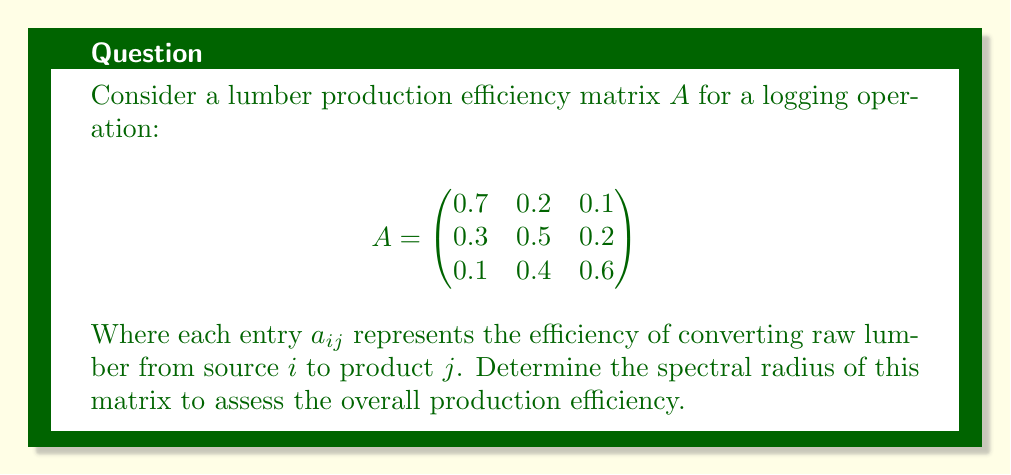Can you answer this question? To find the spectral radius of matrix $A$, we need to:

1) Find the characteristic polynomial:
   $det(A - \lambda I) = 0$
   
   $$\begin{vmatrix}
   0.7-\lambda & 0.2 & 0.1 \\
   0.3 & 0.5-\lambda & 0.2 \\
   0.1 & 0.4 & 0.6-\lambda
   \end{vmatrix} = 0$$

2) Expand the determinant:
   $(0.7-\lambda)[(0.5-\lambda)(0.6-\lambda)-0.08] - 0.2[0.3(0.6-\lambda)-0.02] + 0.1[0.12-0.3(0.5-\lambda)] = 0$

3) Simplify:
   $-\lambda^3 + 1.8\lambda^2 - 0.83\lambda + 0.116 = 0$

4) Find the roots of this polynomial. The largest absolute value of these roots is the spectral radius.

5) Using numerical methods (e.g., Newton-Raphson), we find the roots:
   $\lambda_1 \approx 1.0559$
   $\lambda_2 \approx 0.4220 + 0.2002i$
   $\lambda_3 \approx 0.4220 - 0.2002i$

6) The spectral radius is the largest absolute value among these eigenvalues, which is $|\lambda_1| \approx 1.0559$.
Answer: $1.0559$ 